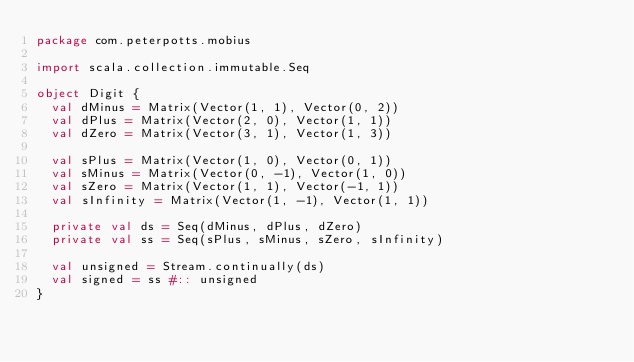<code> <loc_0><loc_0><loc_500><loc_500><_Scala_>package com.peterpotts.mobius

import scala.collection.immutable.Seq

object Digit {
  val dMinus = Matrix(Vector(1, 1), Vector(0, 2))
  val dPlus = Matrix(Vector(2, 0), Vector(1, 1))
  val dZero = Matrix(Vector(3, 1), Vector(1, 3))

  val sPlus = Matrix(Vector(1, 0), Vector(0, 1))
  val sMinus = Matrix(Vector(0, -1), Vector(1, 0))
  val sZero = Matrix(Vector(1, 1), Vector(-1, 1))
  val sInfinity = Matrix(Vector(1, -1), Vector(1, 1))

  private val ds = Seq(dMinus, dPlus, dZero)
  private val ss = Seq(sPlus, sMinus, sZero, sInfinity)

  val unsigned = Stream.continually(ds)
  val signed = ss #:: unsigned
}
</code> 